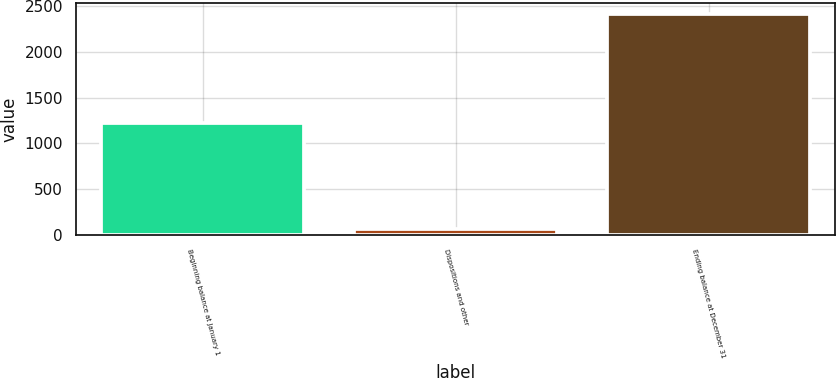Convert chart. <chart><loc_0><loc_0><loc_500><loc_500><bar_chart><fcel>Beginning balance at January 1<fcel>Dispositions and other<fcel>Ending balance at December 31<nl><fcel>1225<fcel>72<fcel>2408<nl></chart> 